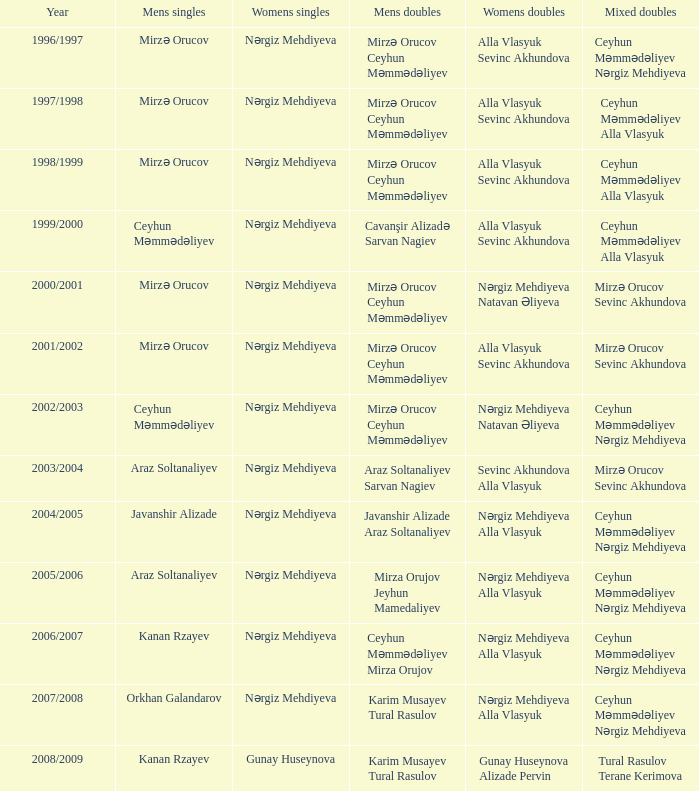Who were the women's doubles players in the 2008/2009 season? Gunay Huseynova Alizade Pervin. 